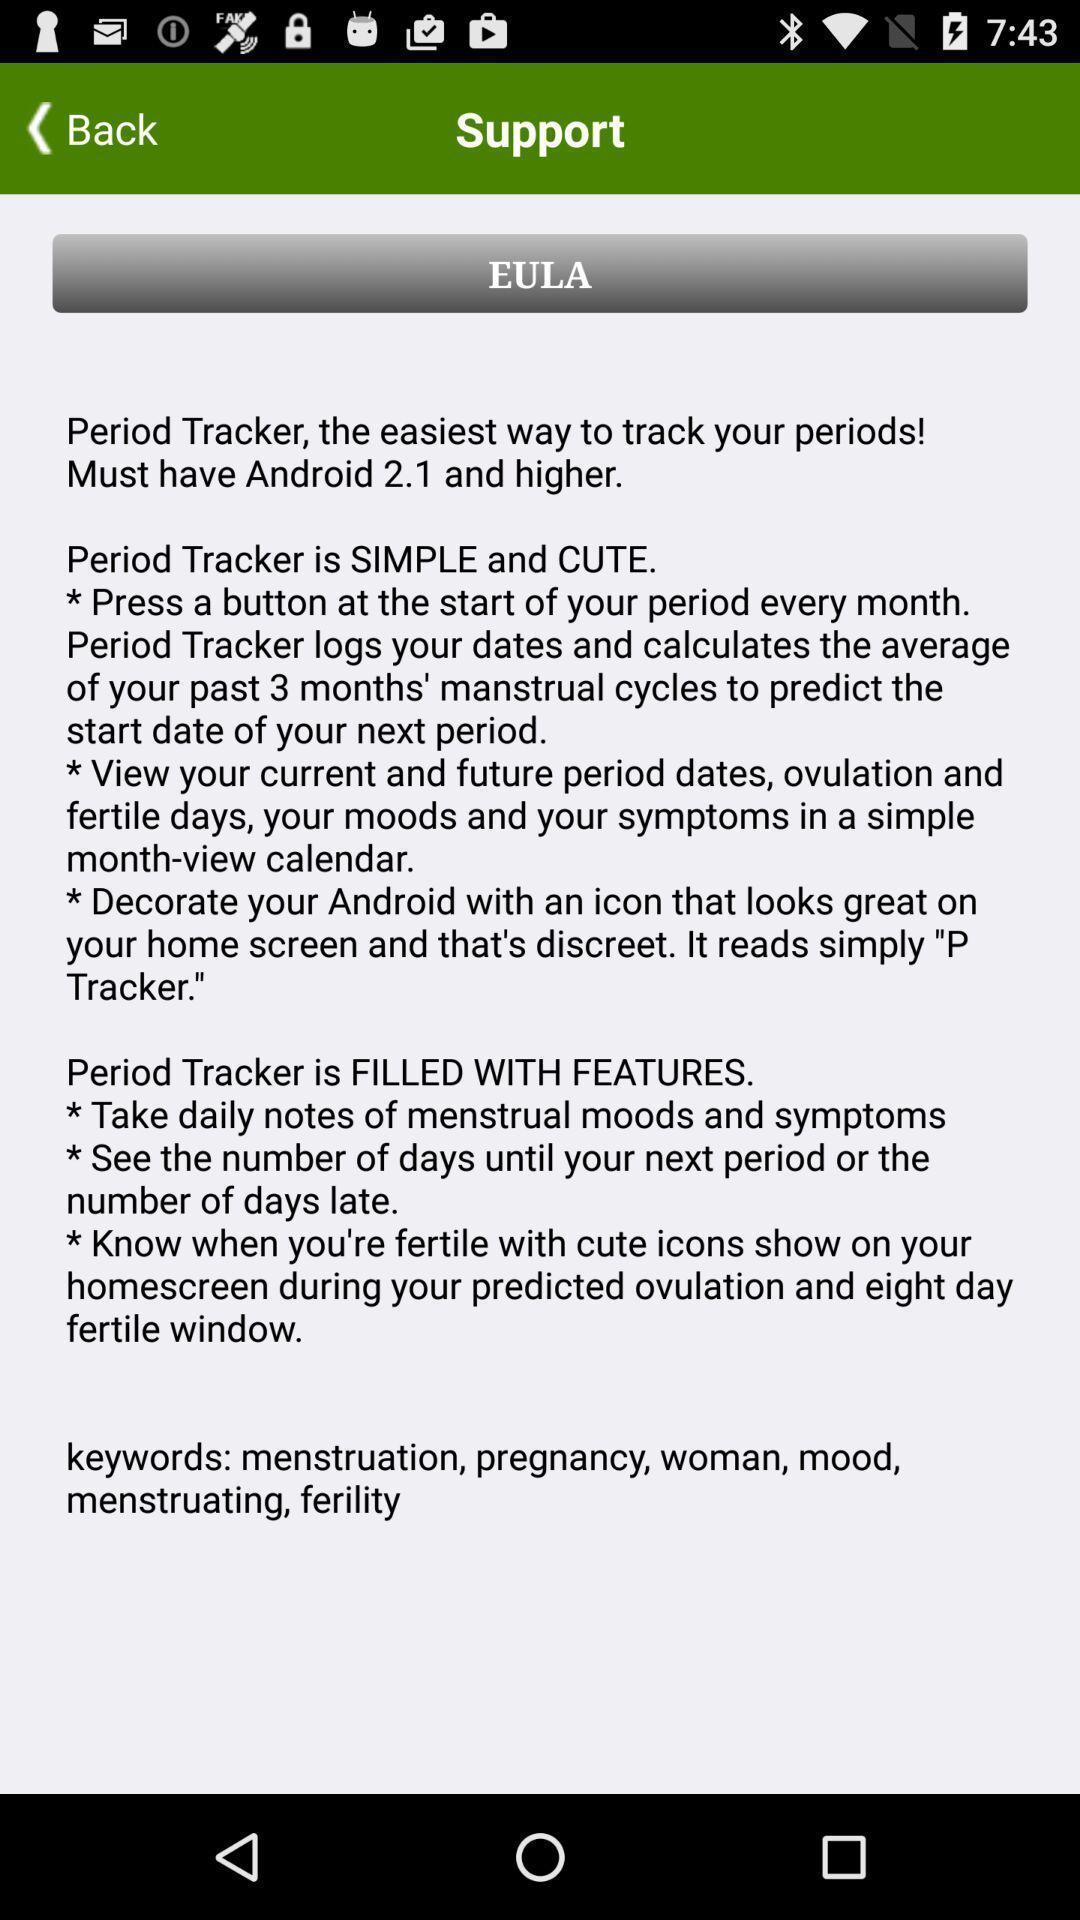Provide a description of this screenshot. Support page. 